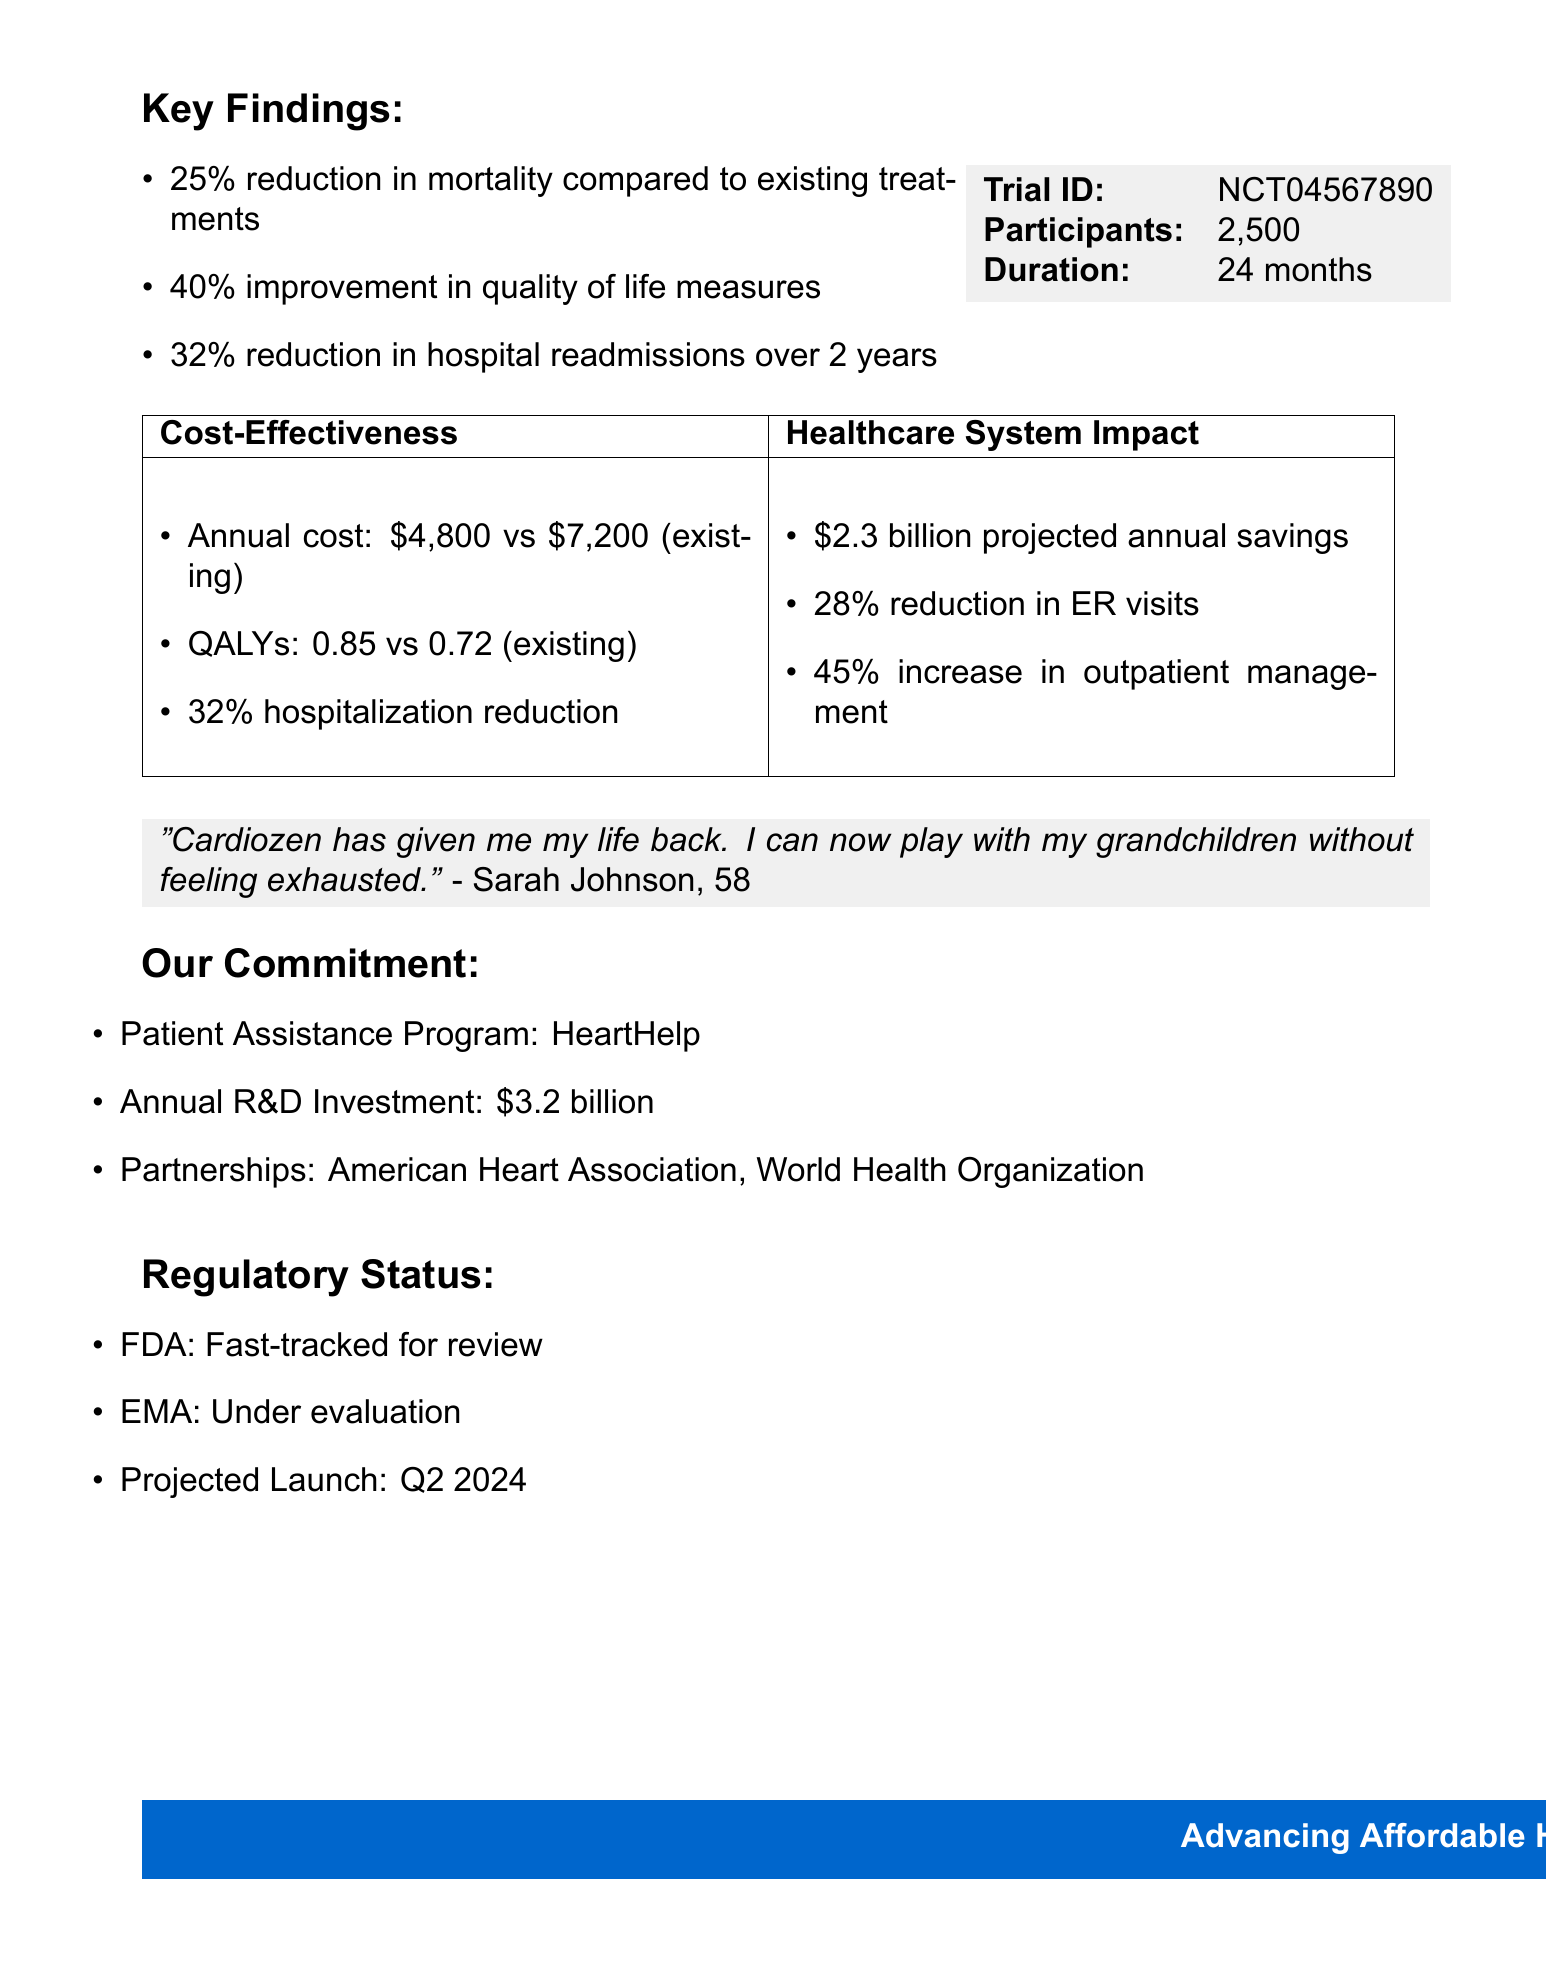What is the drug name? The drug name is mentioned in the document as "Cardiozen."
Answer: Cardiozen How many participants were involved in the trial? The number of participants is stated as "2500" in the document.
Answer: 2500 What is the projected launch date for Cardiozen? The projected launch date is specified as "Q2 2024."
Answer: Q2 2024 What is the annual treatment cost of Cardiozen? The annual treatment cost is highlighted as "$4,800" in comparison to existing treatments.
Answer: $4,800 What percentage reduction in mortality does Cardiozen demonstrate? The document states a "25% reduction" in mortality compared to existing treatments.
Answer: 25% What improvement in quality of life measures do patients report on Cardiozen? The improvement is reported as "40%" according to the key findings in the document.
Answer: 40% Which patient assistance program is mentioned? The patient assistance program is titled "HeartHelp."
Answer: HeartHelp What are the projected annual savings for the healthcare system? Projected annual savings are mentioned as "$2.3 billion" in the healthcare system impact section.
Answer: $2.3 billion Which organizations is the company partnering with? The partnerships include "American Heart Association" and "World Health Organization."
Answer: American Heart Association, World Health Organization 